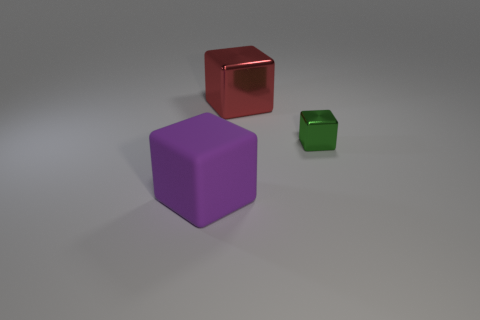Add 1 red rubber cylinders. How many objects exist? 4 Subtract all big matte blocks. Subtract all purple matte blocks. How many objects are left? 1 Add 2 large purple things. How many large purple things are left? 3 Add 1 small blocks. How many small blocks exist? 2 Subtract 0 cyan blocks. How many objects are left? 3 